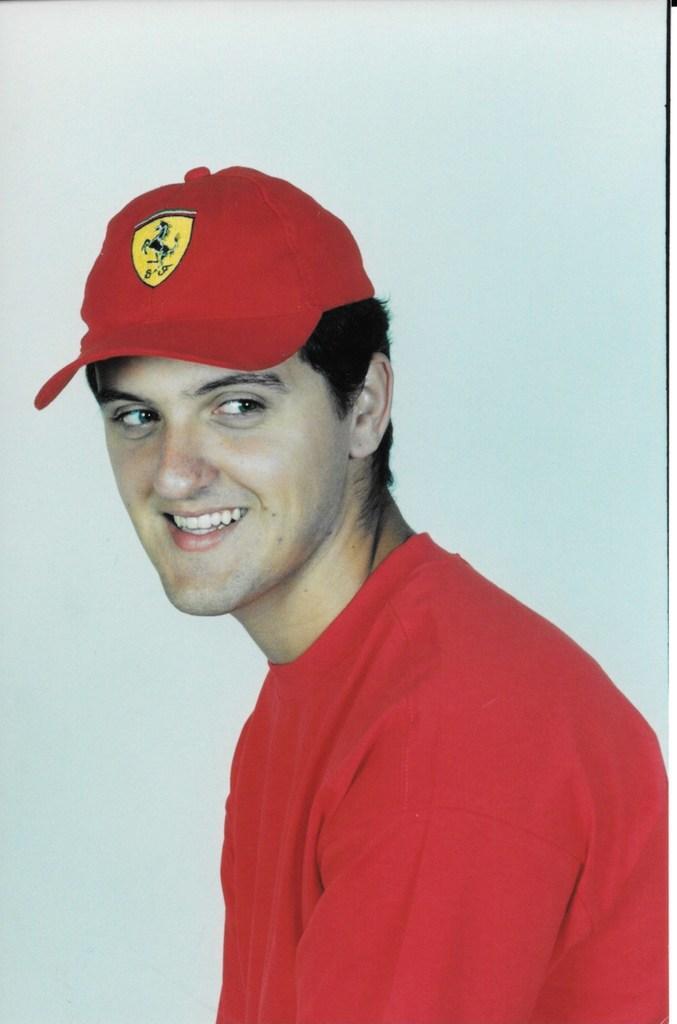How would you summarize this image in a sentence or two? In this image I can see a person wearing a red t shirt and red cap. There is a white background. 